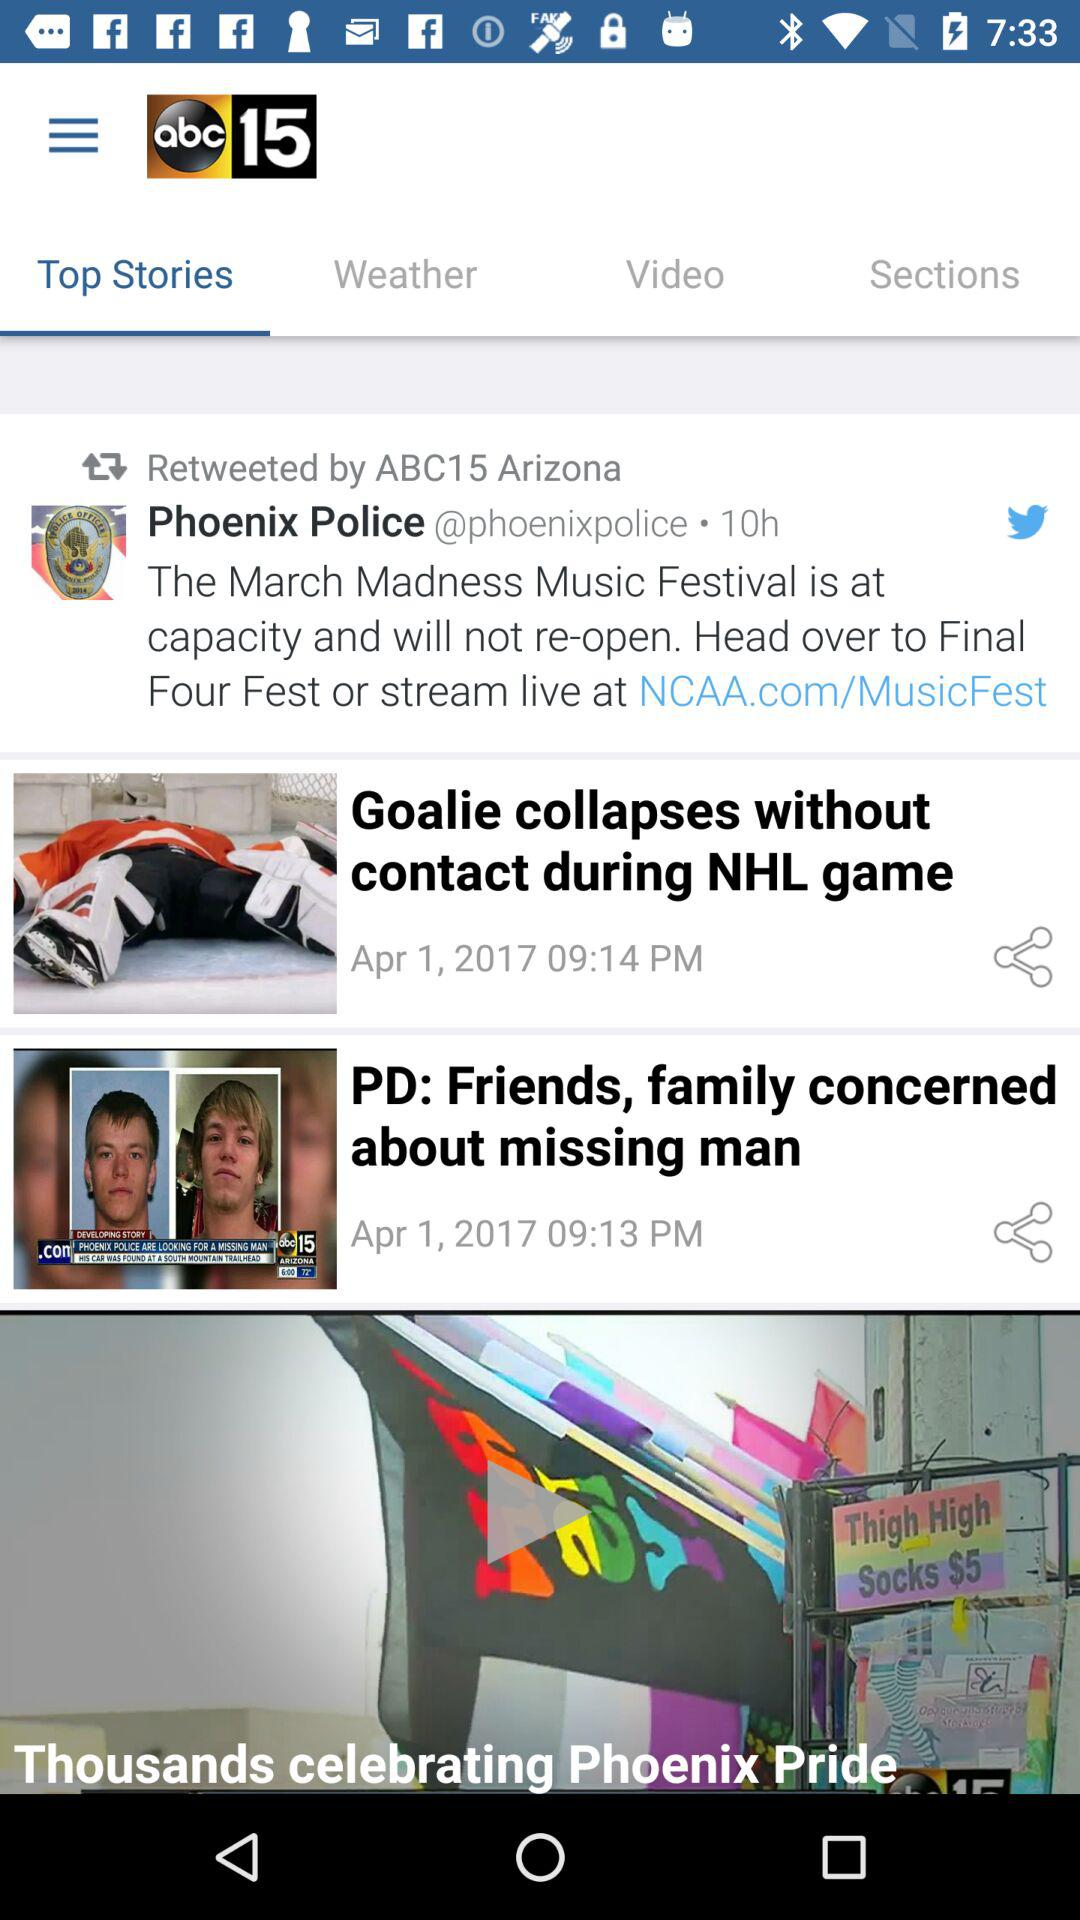What is the date of posting of the "Goalie collapses without contact during NHL game" story? The date of posting is April 1, 2017. 